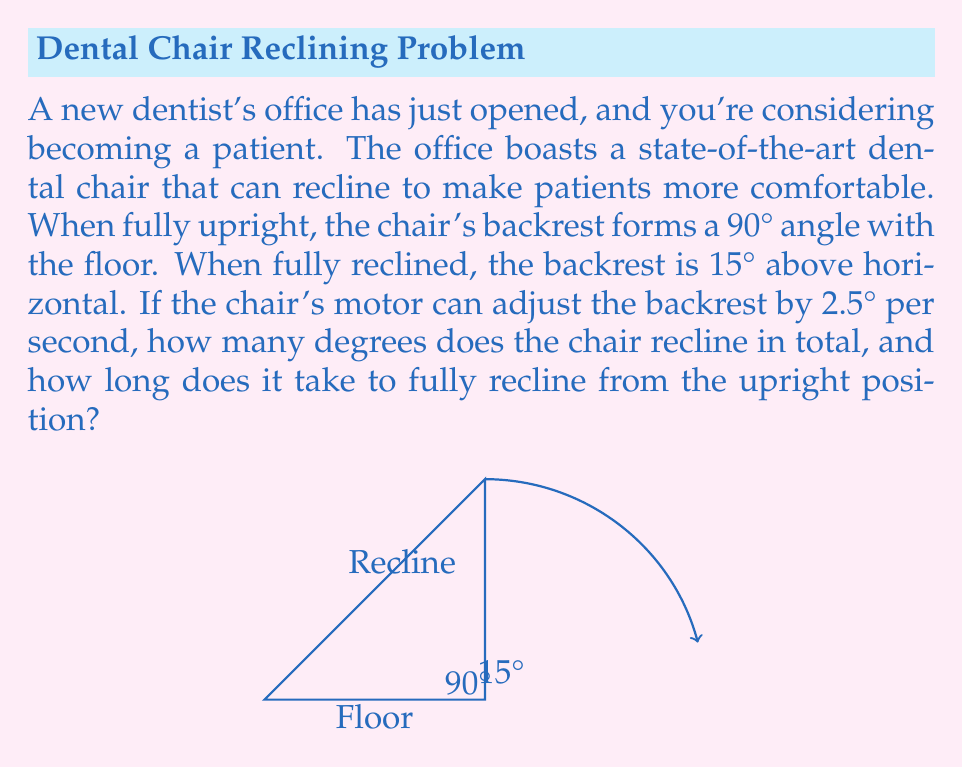Can you solve this math problem? Let's approach this step-by-step:

1) First, we need to calculate the total angle of recline:
   - When upright, the angle with the floor is 90°
   - When fully reclined, the angle with the floor is 15°
   - Total angle of recline = $90° - 15° = 75°$

2) Now, let's calculate the time it takes to fully recline:
   - The chair adjusts at a rate of 2.5° per second
   - Time = Total angle ÷ Rate of adjustment
   - Time = $75° ÷ 2.5°/s = 30$ seconds

Therefore, the chair reclines a total of 75°, and it takes 30 seconds to fully recline from the upright position.
Answer: 75°, 30 seconds 